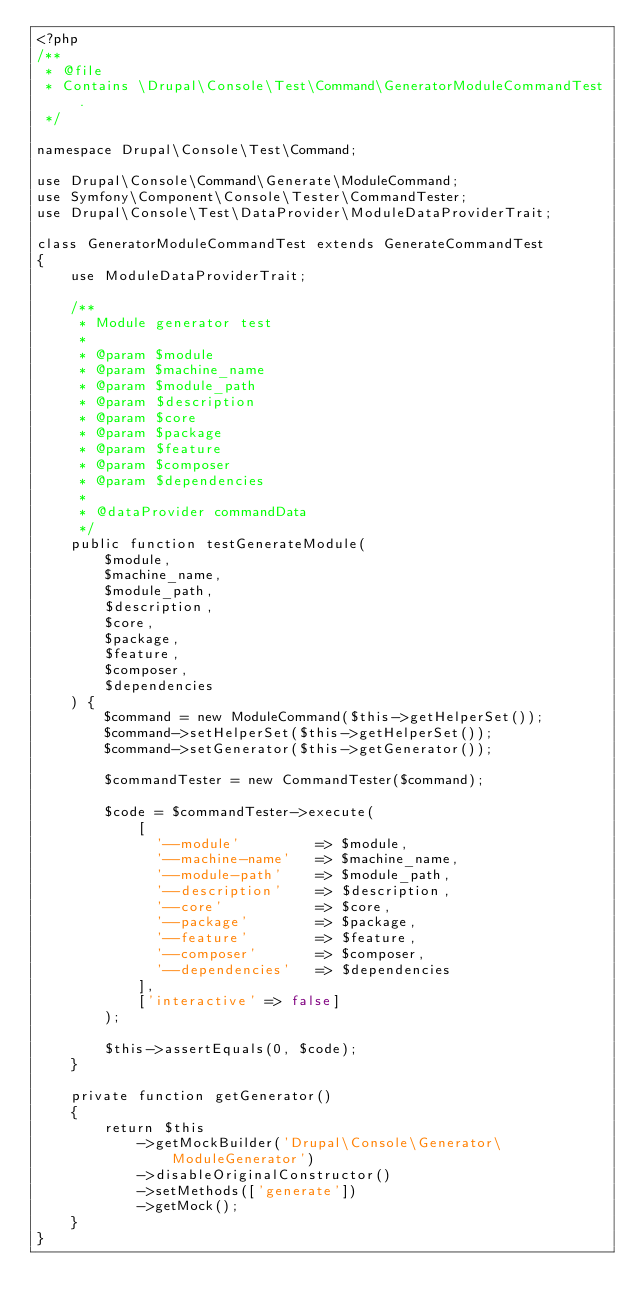<code> <loc_0><loc_0><loc_500><loc_500><_PHP_><?php
/**
 * @file
 * Contains \Drupal\Console\Test\Command\GeneratorModuleCommandTest.
 */

namespace Drupal\Console\Test\Command;

use Drupal\Console\Command\Generate\ModuleCommand;
use Symfony\Component\Console\Tester\CommandTester;
use Drupal\Console\Test\DataProvider\ModuleDataProviderTrait;

class GeneratorModuleCommandTest extends GenerateCommandTest
{
    use ModuleDataProviderTrait;

    /**
     * Module generator test
     *
     * @param $module
     * @param $machine_name
     * @param $module_path
     * @param $description
     * @param $core
     * @param $package
     * @param $feature
     * @param $composer
     * @param $dependencies
     *
     * @dataProvider commandData
     */
    public function testGenerateModule(
        $module,
        $machine_name,
        $module_path,
        $description,
        $core,
        $package,
        $feature,
        $composer,
        $dependencies
    ) {
        $command = new ModuleCommand($this->getHelperSet());
        $command->setHelperSet($this->getHelperSet());
        $command->setGenerator($this->getGenerator());

        $commandTester = new CommandTester($command);

        $code = $commandTester->execute(
            [
              '--module'         => $module,
              '--machine-name'   => $machine_name,
              '--module-path'    => $module_path,
              '--description'    => $description,
              '--core'           => $core,
              '--package'        => $package,
              '--feature'        => $feature,
              '--composer'       => $composer,
              '--dependencies'   => $dependencies
            ],
            ['interactive' => false]
        );

        $this->assertEquals(0, $code);
    }

    private function getGenerator()
    {
        return $this
            ->getMockBuilder('Drupal\Console\Generator\ModuleGenerator')
            ->disableOriginalConstructor()
            ->setMethods(['generate'])
            ->getMock();
    }
}
</code> 